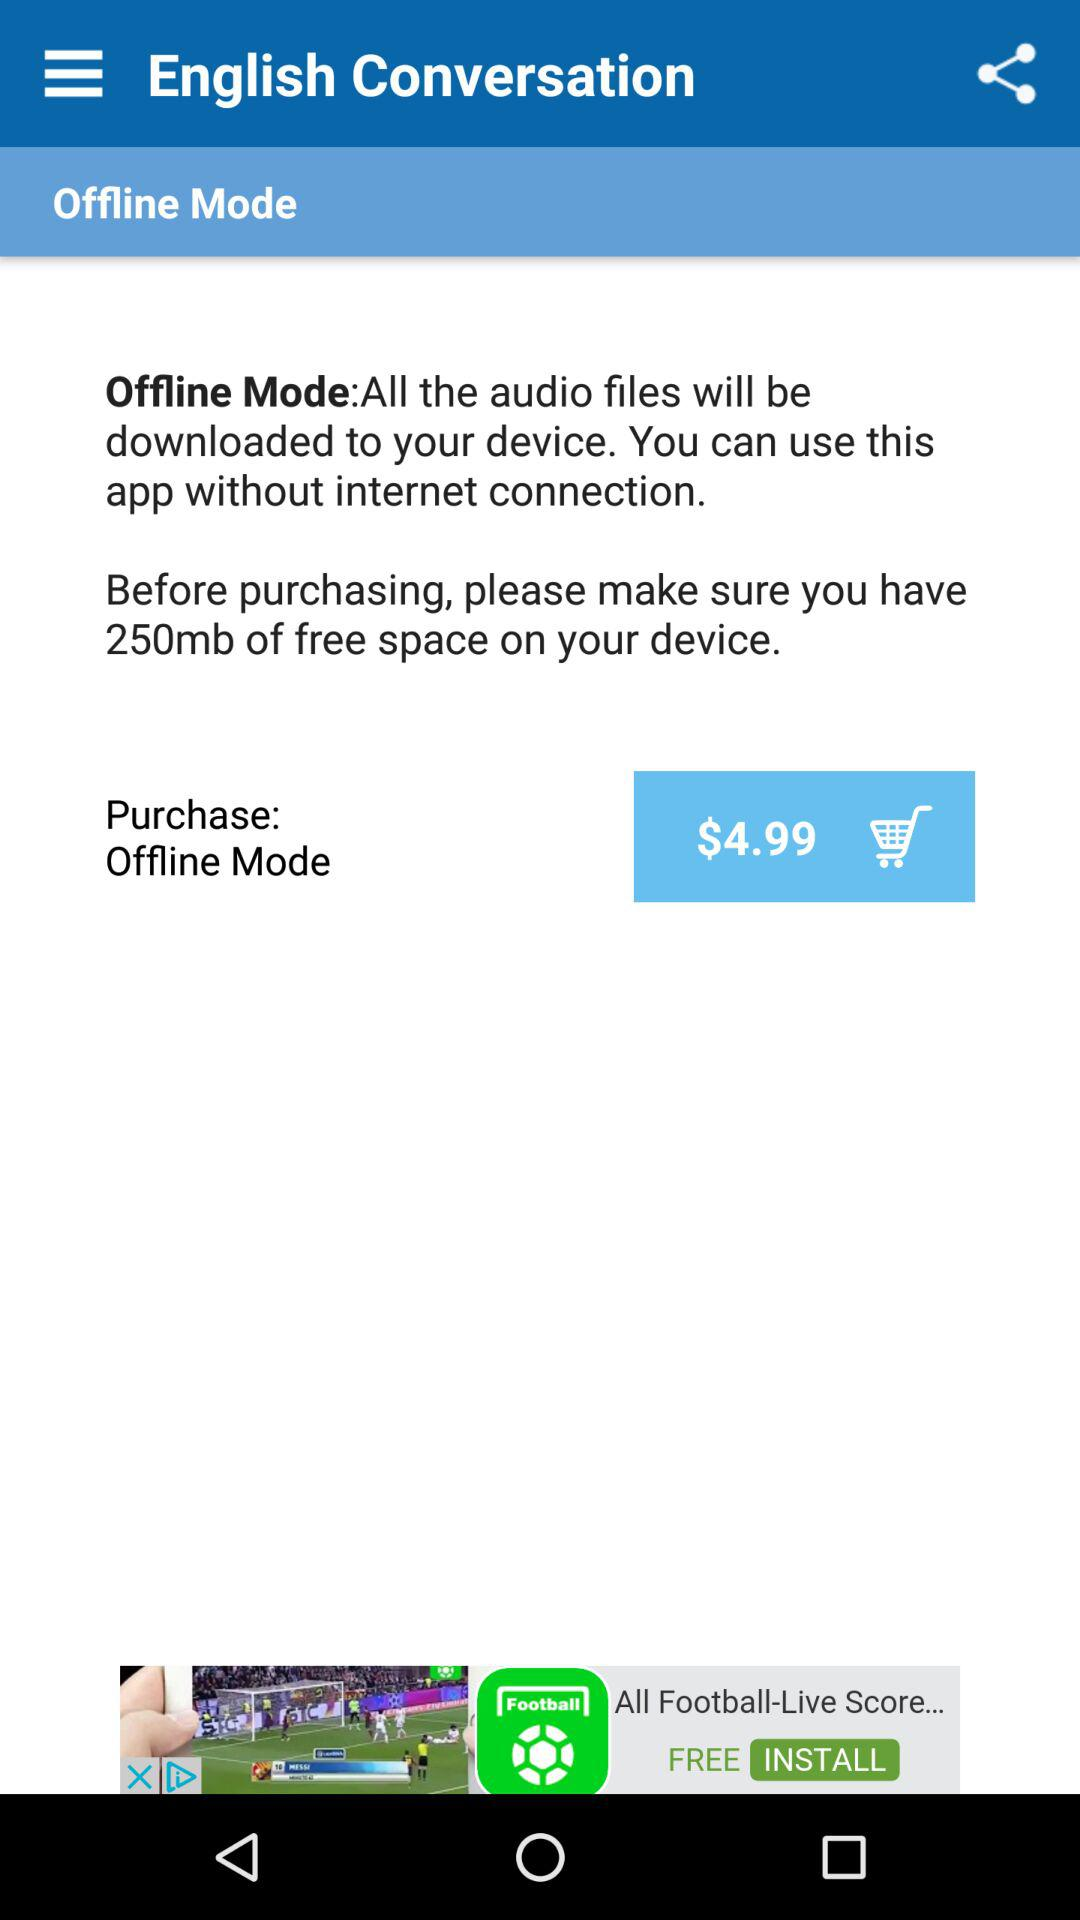What is the price? The price is $4.99. 